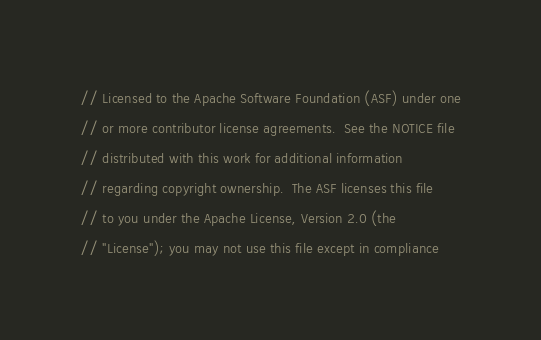Convert code to text. <code><loc_0><loc_0><loc_500><loc_500><_C_>// Licensed to the Apache Software Foundation (ASF) under one
// or more contributor license agreements.  See the NOTICE file
// distributed with this work for additional information
// regarding copyright ownership.  The ASF licenses this file
// to you under the Apache License, Version 2.0 (the
// "License"); you may not use this file except in compliance</code> 